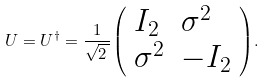Convert formula to latex. <formula><loc_0><loc_0><loc_500><loc_500>U = U ^ { \dagger } = { \frac { 1 } { \sqrt { 2 \, } } } { \left ( \begin{array} { l l } { I _ { 2 } } & { \sigma ^ { 2 } } \\ { \sigma ^ { 2 } } & { - I _ { 2 } } \end{array} \right ) } .</formula> 